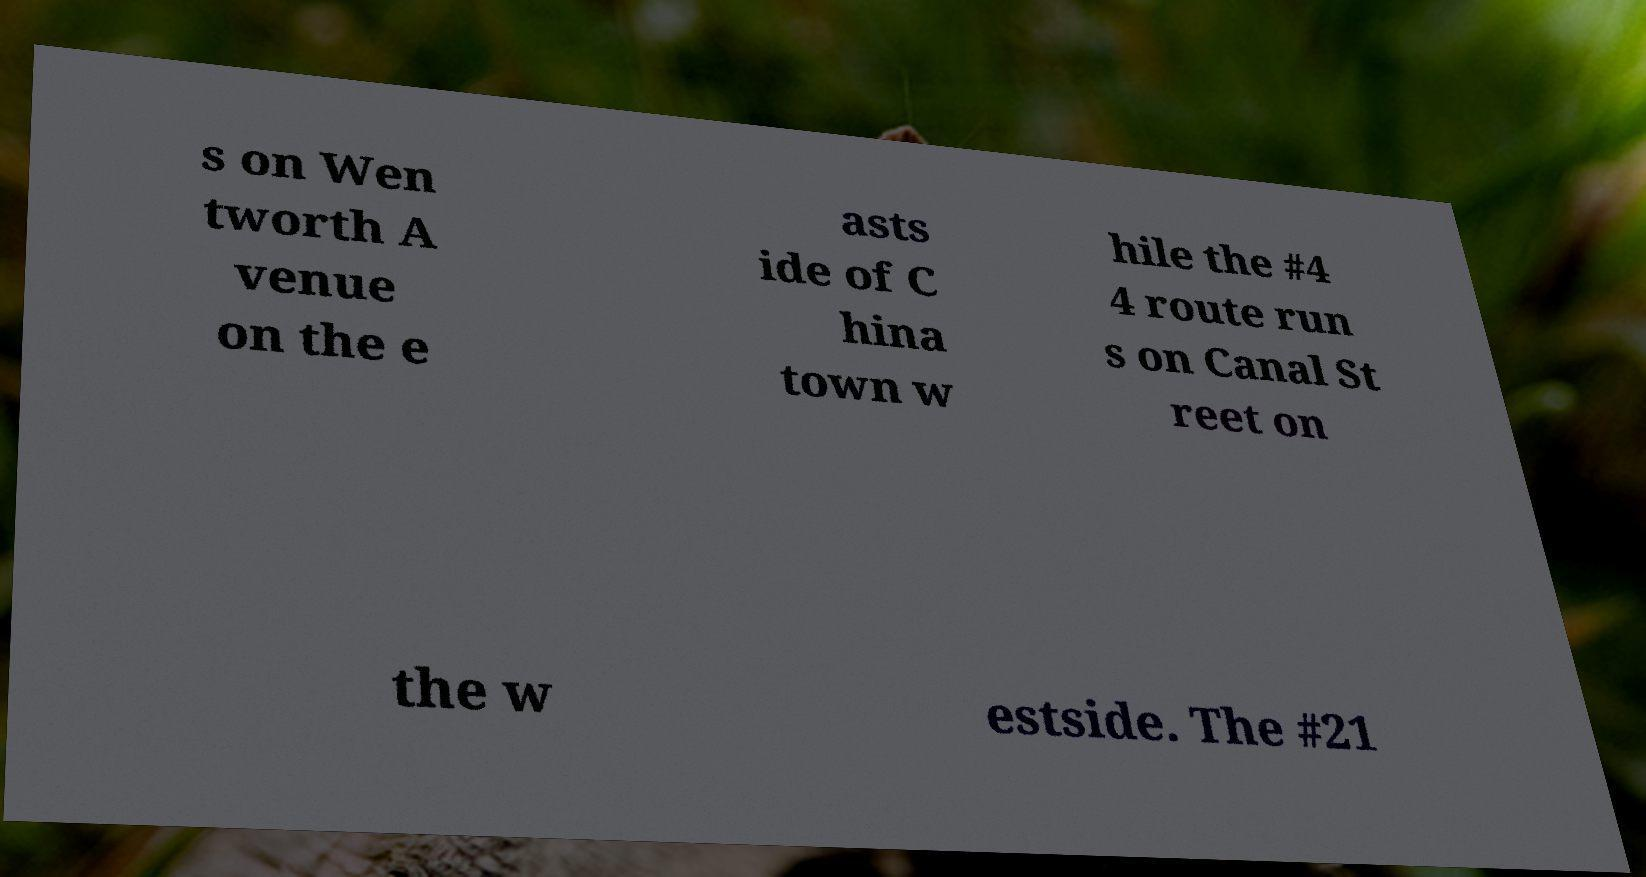Please read and relay the text visible in this image. What does it say? s on Wen tworth A venue on the e asts ide of C hina town w hile the #4 4 route run s on Canal St reet on the w estside. The #21 